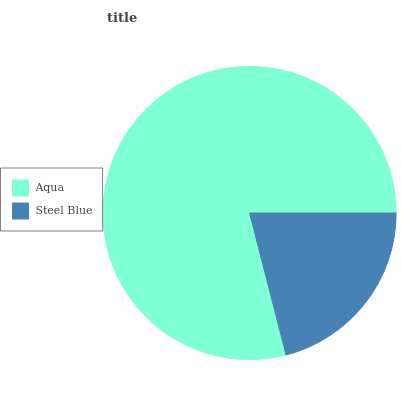Is Steel Blue the minimum?
Answer yes or no. Yes. Is Aqua the maximum?
Answer yes or no. Yes. Is Steel Blue the maximum?
Answer yes or no. No. Is Aqua greater than Steel Blue?
Answer yes or no. Yes. Is Steel Blue less than Aqua?
Answer yes or no. Yes. Is Steel Blue greater than Aqua?
Answer yes or no. No. Is Aqua less than Steel Blue?
Answer yes or no. No. Is Aqua the high median?
Answer yes or no. Yes. Is Steel Blue the low median?
Answer yes or no. Yes. Is Steel Blue the high median?
Answer yes or no. No. Is Aqua the low median?
Answer yes or no. No. 